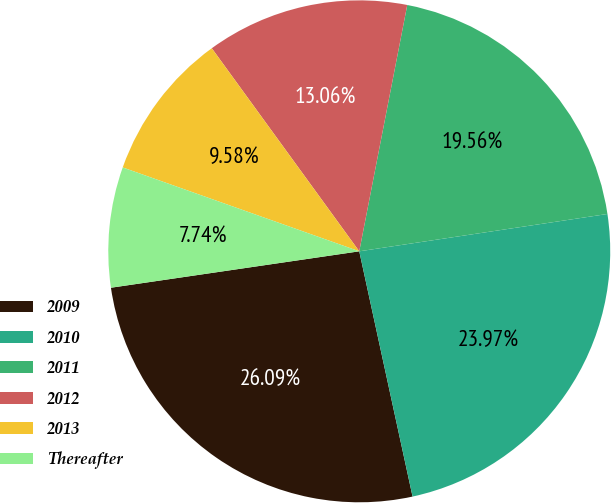Convert chart to OTSL. <chart><loc_0><loc_0><loc_500><loc_500><pie_chart><fcel>2009<fcel>2010<fcel>2011<fcel>2012<fcel>2013<fcel>Thereafter<nl><fcel>26.09%<fcel>23.97%<fcel>19.56%<fcel>13.06%<fcel>9.58%<fcel>7.74%<nl></chart> 